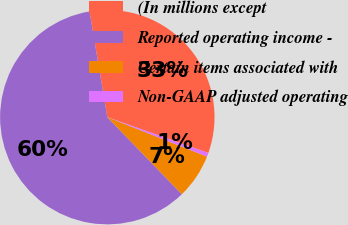Convert chart to OTSL. <chart><loc_0><loc_0><loc_500><loc_500><pie_chart><fcel>(In millions except<fcel>Reported operating income -<fcel>Certain items associated with<fcel>Non-GAAP adjusted operating<nl><fcel>33.08%<fcel>59.57%<fcel>6.77%<fcel>0.57%<nl></chart> 